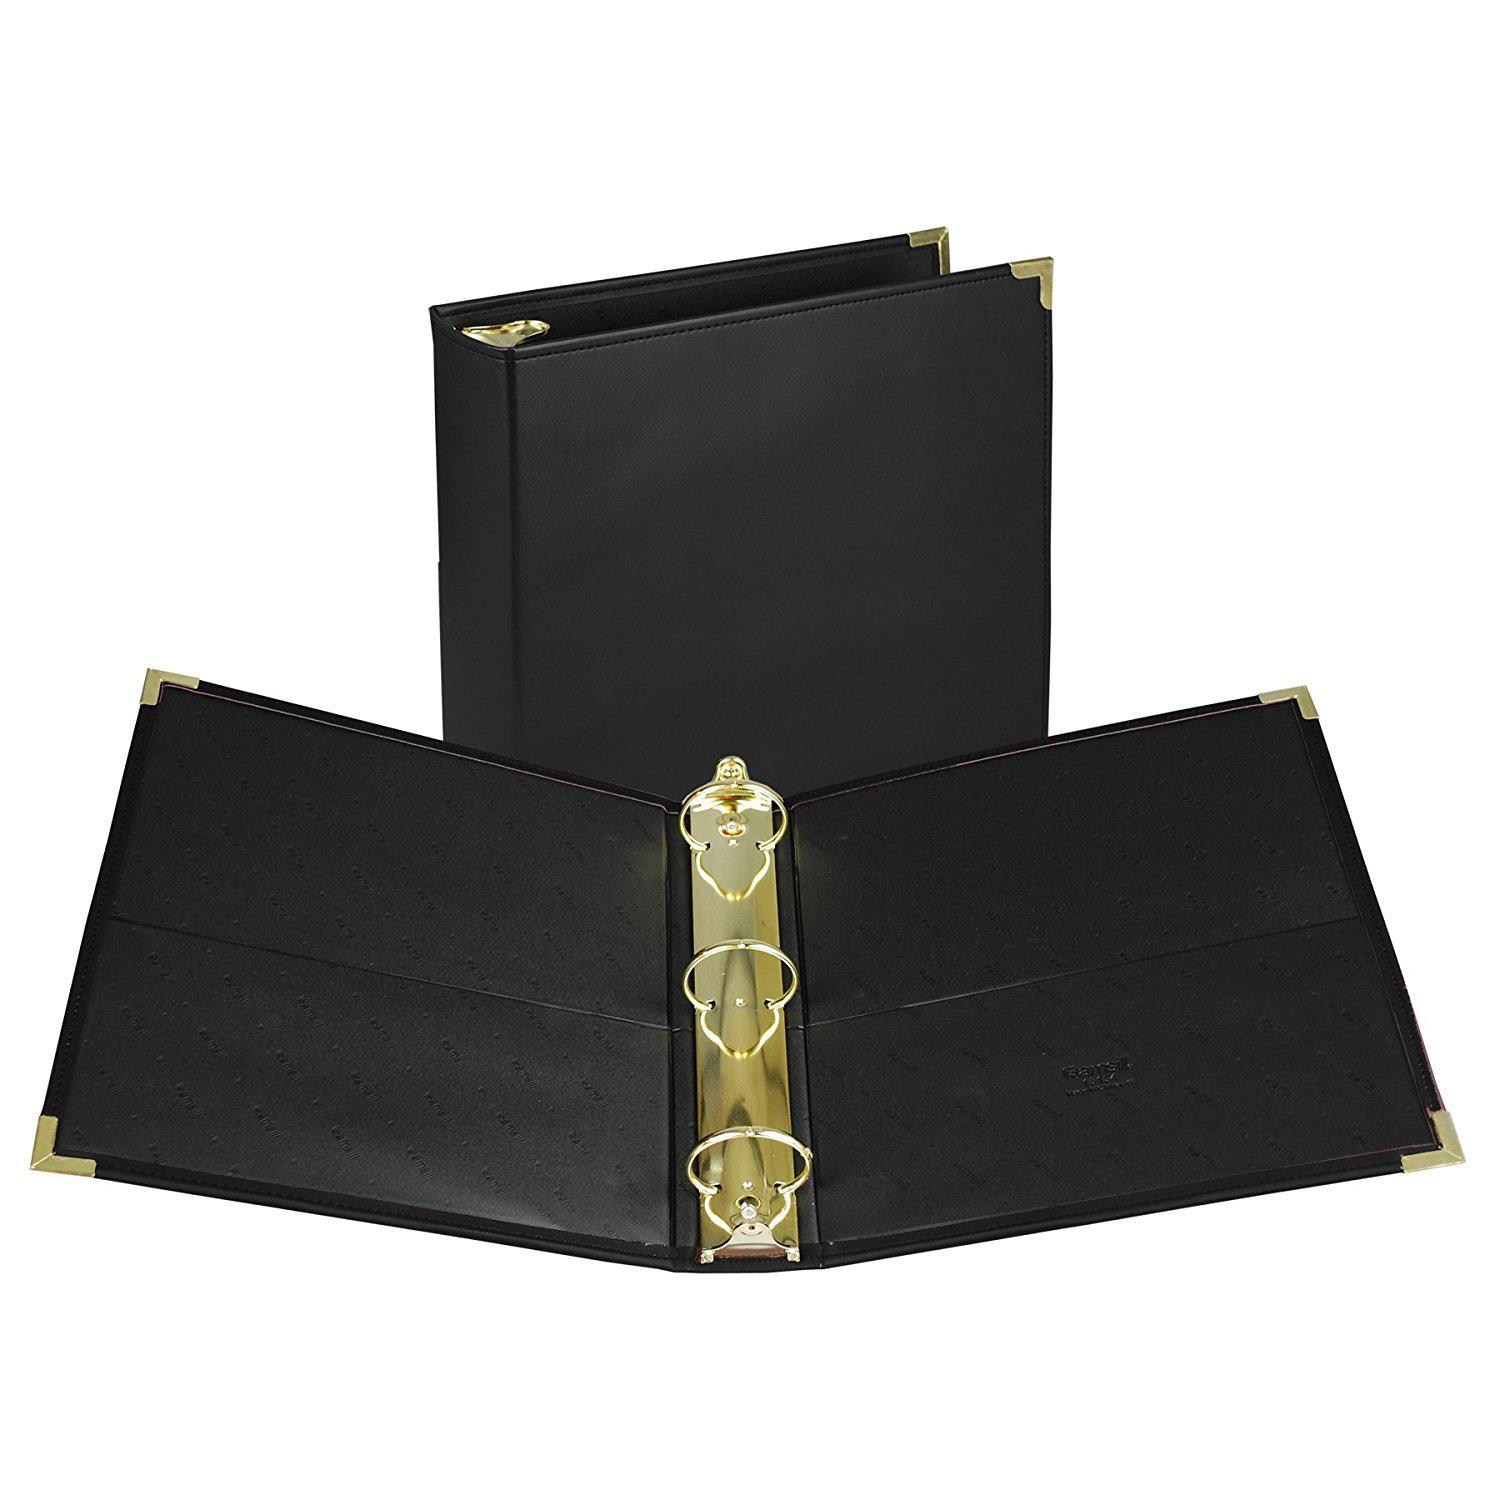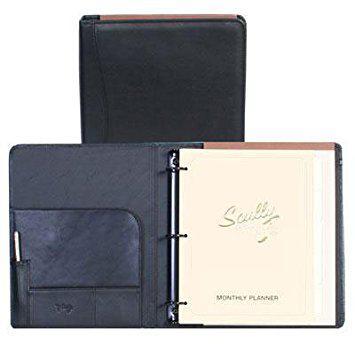The first image is the image on the left, the second image is the image on the right. Given the left and right images, does the statement "Left image shows an open binder with paper in it." hold true? Answer yes or no. No. The first image is the image on the left, the second image is the image on the right. Considering the images on both sides, is "One image shows a leather notebook both opened and closed, while the second image shows one or more notebooks, but only one opened." valid? Answer yes or no. Yes. 